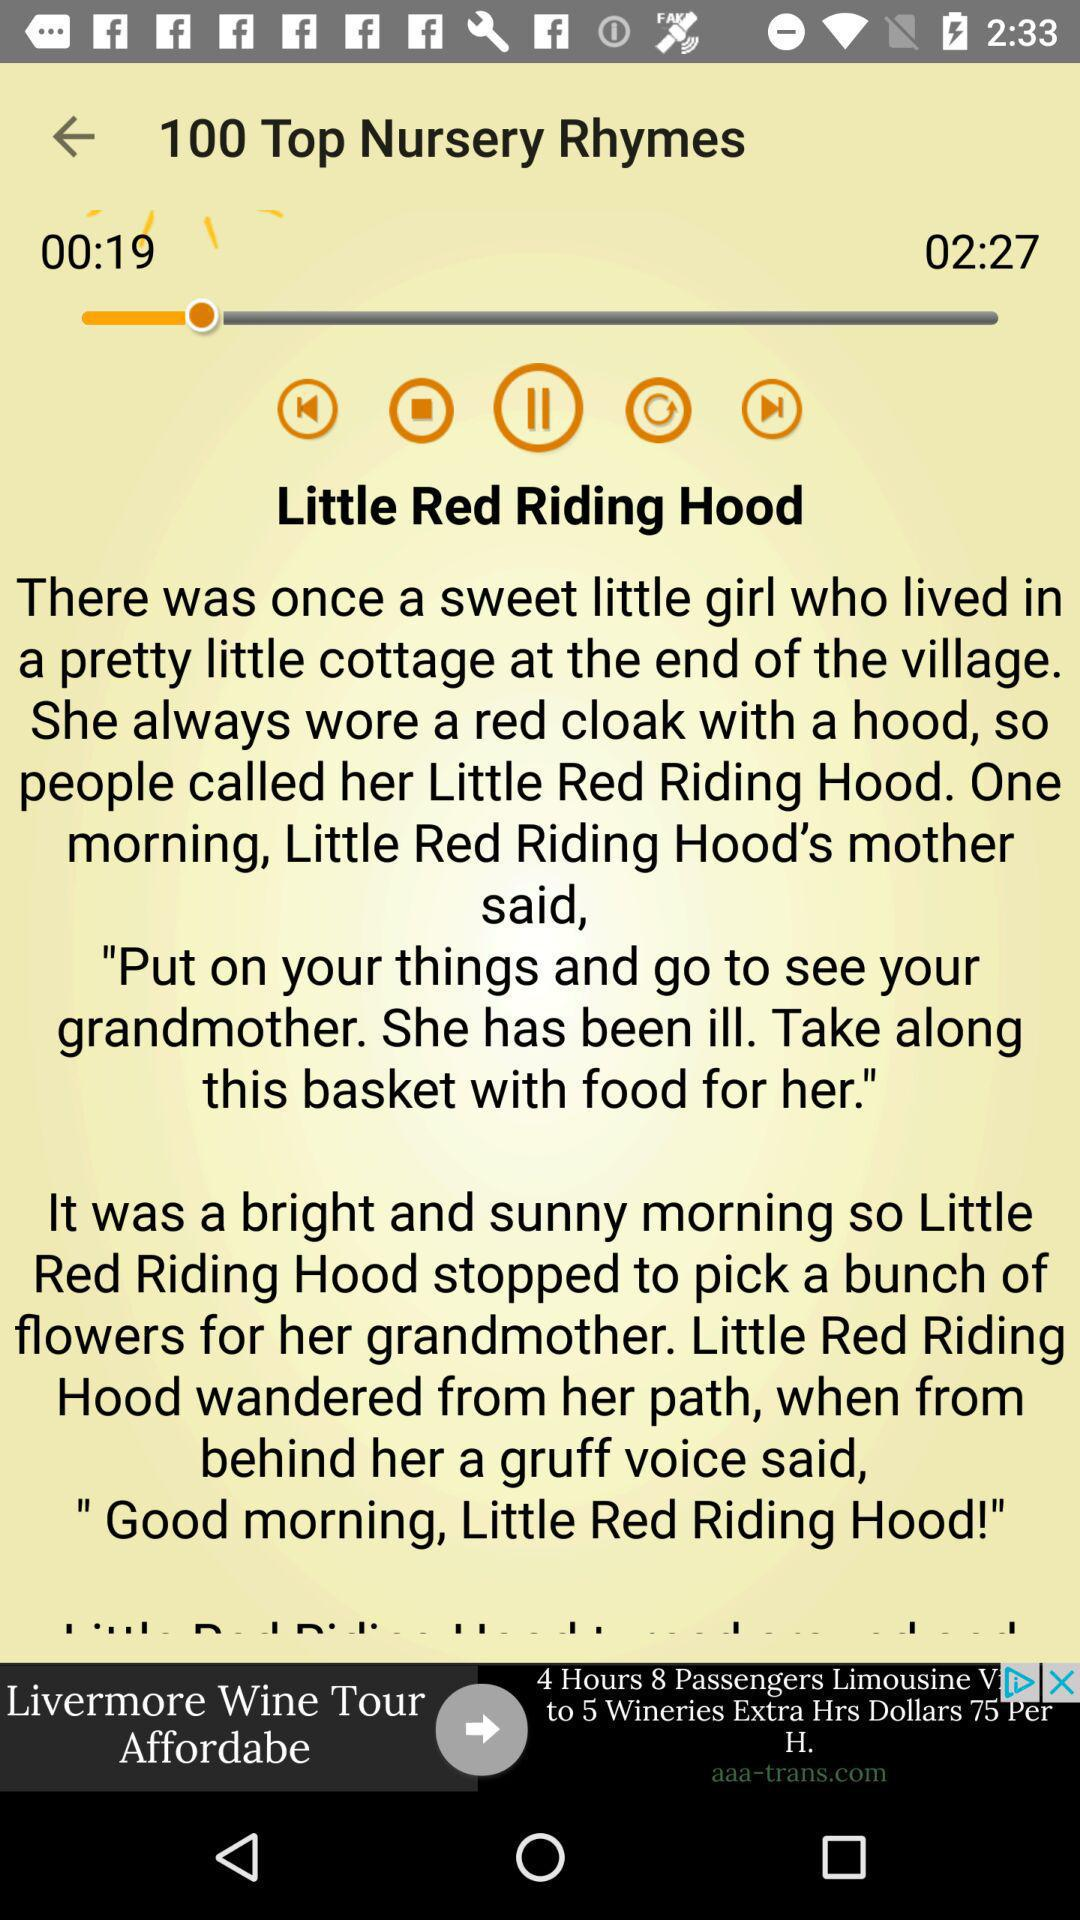How many rhymes are there? There are 100 rhymes. 